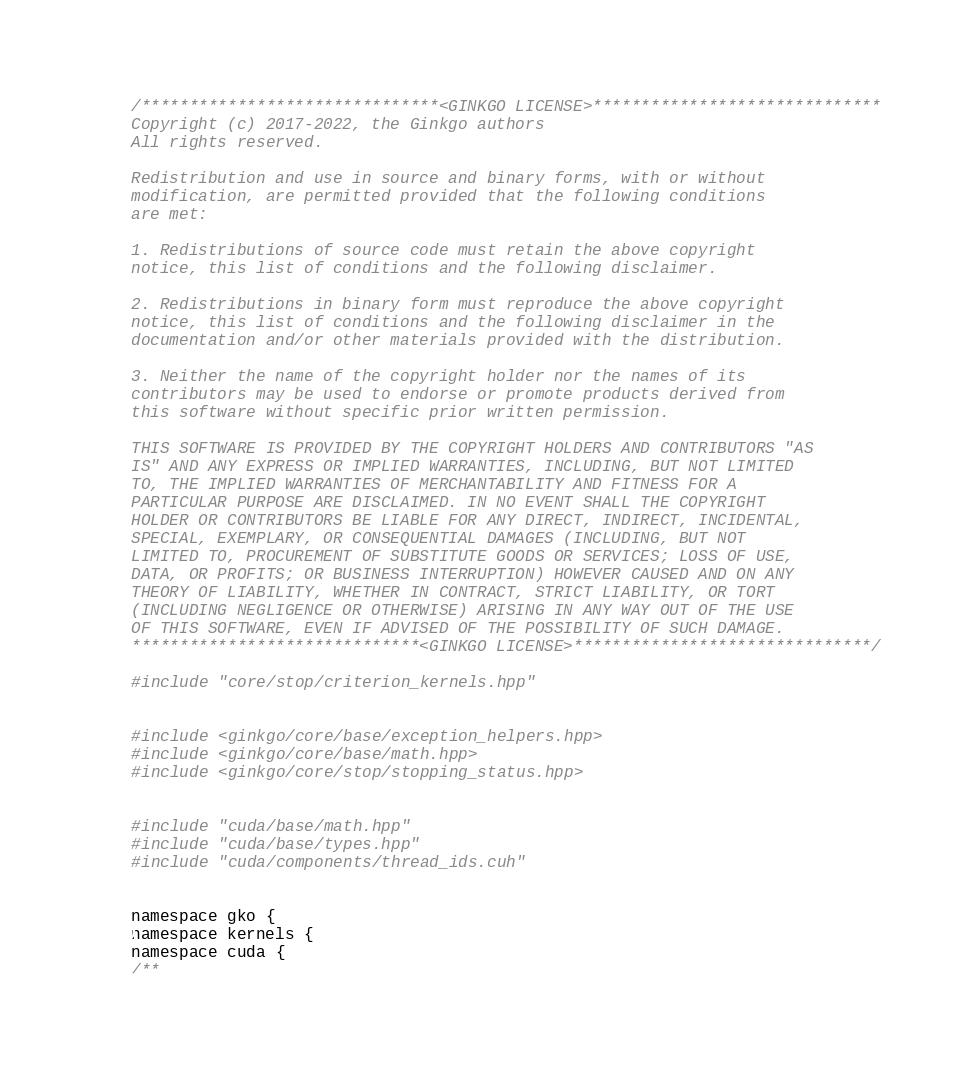Convert code to text. <code><loc_0><loc_0><loc_500><loc_500><_Cuda_>/*******************************<GINKGO LICENSE>******************************
Copyright (c) 2017-2022, the Ginkgo authors
All rights reserved.

Redistribution and use in source and binary forms, with or without
modification, are permitted provided that the following conditions
are met:

1. Redistributions of source code must retain the above copyright
notice, this list of conditions and the following disclaimer.

2. Redistributions in binary form must reproduce the above copyright
notice, this list of conditions and the following disclaimer in the
documentation and/or other materials provided with the distribution.

3. Neither the name of the copyright holder nor the names of its
contributors may be used to endorse or promote products derived from
this software without specific prior written permission.

THIS SOFTWARE IS PROVIDED BY THE COPYRIGHT HOLDERS AND CONTRIBUTORS "AS
IS" AND ANY EXPRESS OR IMPLIED WARRANTIES, INCLUDING, BUT NOT LIMITED
TO, THE IMPLIED WARRANTIES OF MERCHANTABILITY AND FITNESS FOR A
PARTICULAR PURPOSE ARE DISCLAIMED. IN NO EVENT SHALL THE COPYRIGHT
HOLDER OR CONTRIBUTORS BE LIABLE FOR ANY DIRECT, INDIRECT, INCIDENTAL,
SPECIAL, EXEMPLARY, OR CONSEQUENTIAL DAMAGES (INCLUDING, BUT NOT
LIMITED TO, PROCUREMENT OF SUBSTITUTE GOODS OR SERVICES; LOSS OF USE,
DATA, OR PROFITS; OR BUSINESS INTERRUPTION) HOWEVER CAUSED AND ON ANY
THEORY OF LIABILITY, WHETHER IN CONTRACT, STRICT LIABILITY, OR TORT
(INCLUDING NEGLIGENCE OR OTHERWISE) ARISING IN ANY WAY OUT OF THE USE
OF THIS SOFTWARE, EVEN IF ADVISED OF THE POSSIBILITY OF SUCH DAMAGE.
******************************<GINKGO LICENSE>*******************************/

#include "core/stop/criterion_kernels.hpp"


#include <ginkgo/core/base/exception_helpers.hpp>
#include <ginkgo/core/base/math.hpp>
#include <ginkgo/core/stop/stopping_status.hpp>


#include "cuda/base/math.hpp"
#include "cuda/base/types.hpp"
#include "cuda/components/thread_ids.cuh"


namespace gko {
namespace kernels {
namespace cuda {
/**</code> 